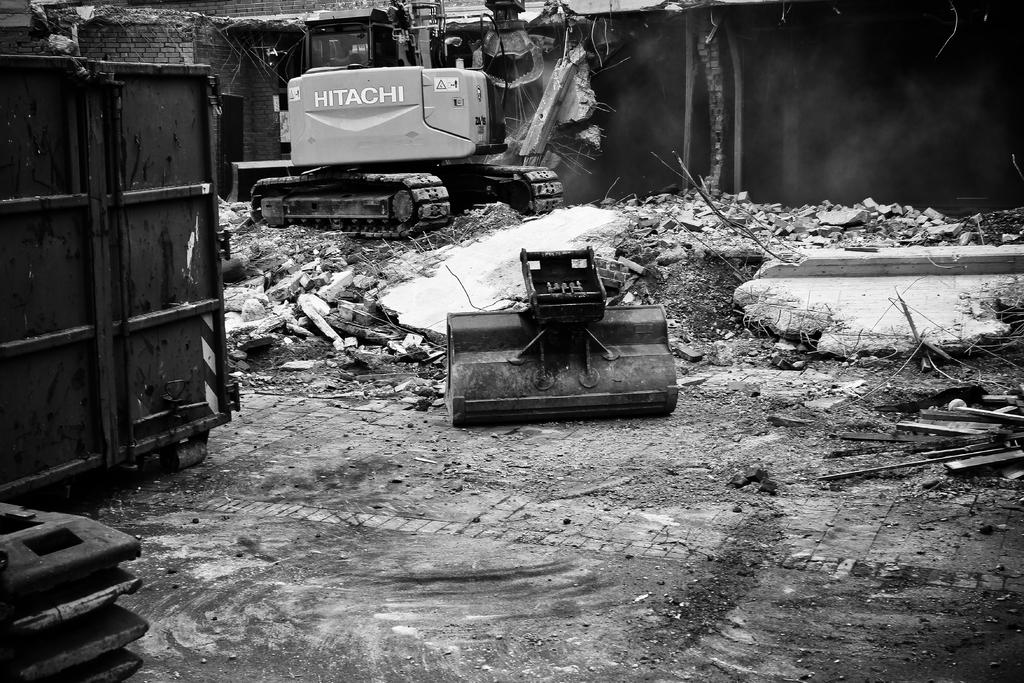What is the color scheme of the image? The image is black and white. What is the main subject in the image? There is a crane in the image. What can be seen in the background of the image? There are destroyed buildings in the background of the image. How many visitors are present in the image? There is no indication of any visitors in the image. What part of the crane is shown in the image? The entire crane is visible in the image, so it is not possible to identify a specific part. 